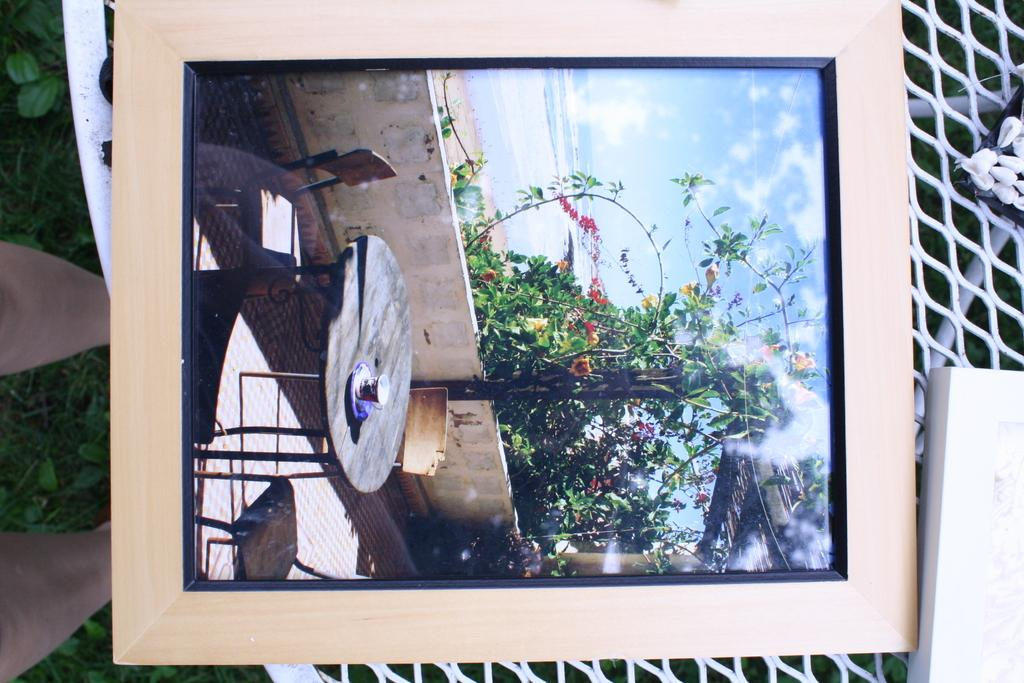What is on the table in the image? There is a photo frame on the table, along with other objects. Can you describe the other objects on the table? Unfortunately, the provided facts do not specify the other objects on the table. What can be seen on the left side of the image? The legs of a person are visible on the surface of the grass on the left side of the image. What type of plough is being used to start the engine in the image? There is no plough or engine present in the image; it features a photo frame on a table and a person's legs on the grass. 